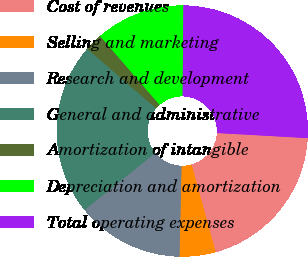Convert chart to OTSL. <chart><loc_0><loc_0><loc_500><loc_500><pie_chart><fcel>Cost of revenues<fcel>Selling and marketing<fcel>Research and development<fcel>General and administrative<fcel>Amortization of intangible<fcel>Depreciation and amortization<fcel>Total operating expenses<nl><fcel>19.82%<fcel>4.64%<fcel>13.84%<fcel>22.16%<fcel>2.29%<fcel>11.49%<fcel>25.75%<nl></chart> 